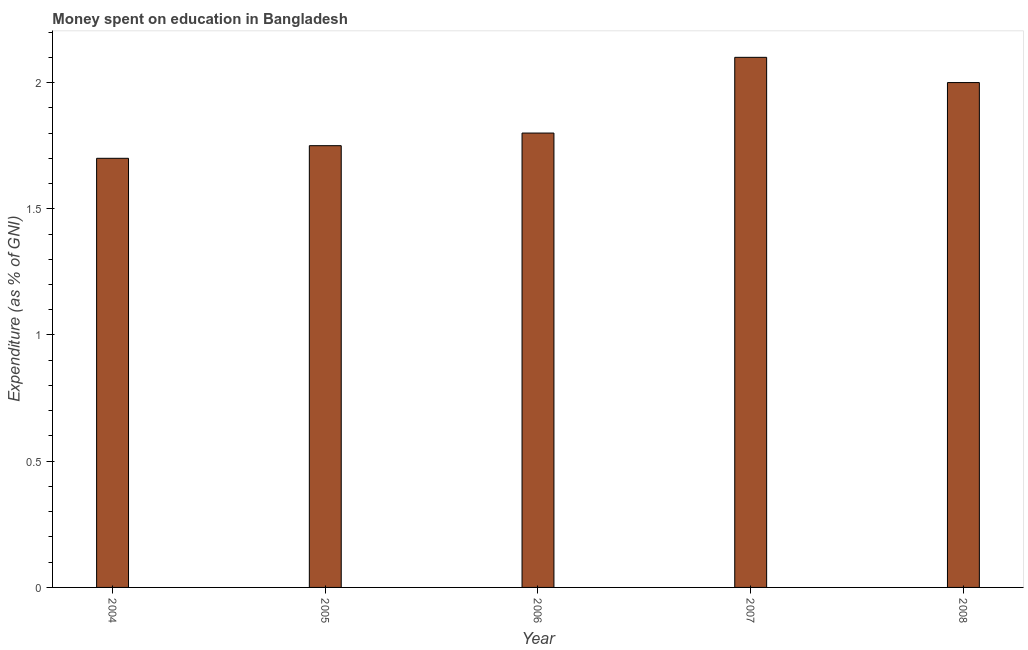What is the title of the graph?
Your answer should be compact. Money spent on education in Bangladesh. What is the label or title of the Y-axis?
Make the answer very short. Expenditure (as % of GNI). Across all years, what is the minimum expenditure on education?
Keep it short and to the point. 1.7. In which year was the expenditure on education minimum?
Provide a succinct answer. 2004. What is the sum of the expenditure on education?
Ensure brevity in your answer.  9.35. What is the difference between the expenditure on education in 2005 and 2008?
Provide a short and direct response. -0.25. What is the average expenditure on education per year?
Make the answer very short. 1.87. What is the median expenditure on education?
Your answer should be very brief. 1.8. What is the ratio of the expenditure on education in 2005 to that in 2007?
Offer a very short reply. 0.83. Is the expenditure on education in 2007 less than that in 2008?
Give a very brief answer. No. Is the sum of the expenditure on education in 2004 and 2006 greater than the maximum expenditure on education across all years?
Provide a short and direct response. Yes. What is the difference between the highest and the lowest expenditure on education?
Make the answer very short. 0.4. In how many years, is the expenditure on education greater than the average expenditure on education taken over all years?
Your response must be concise. 2. Are all the bars in the graph horizontal?
Offer a very short reply. No. Are the values on the major ticks of Y-axis written in scientific E-notation?
Keep it short and to the point. No. What is the Expenditure (as % of GNI) of 2004?
Make the answer very short. 1.7. What is the Expenditure (as % of GNI) of 2005?
Offer a very short reply. 1.75. What is the Expenditure (as % of GNI) in 2007?
Ensure brevity in your answer.  2.1. What is the Expenditure (as % of GNI) in 2008?
Offer a terse response. 2. What is the difference between the Expenditure (as % of GNI) in 2004 and 2005?
Offer a terse response. -0.05. What is the difference between the Expenditure (as % of GNI) in 2004 and 2007?
Keep it short and to the point. -0.4. What is the difference between the Expenditure (as % of GNI) in 2005 and 2007?
Provide a succinct answer. -0.35. What is the difference between the Expenditure (as % of GNI) in 2005 and 2008?
Your response must be concise. -0.25. What is the difference between the Expenditure (as % of GNI) in 2006 and 2007?
Provide a short and direct response. -0.3. What is the difference between the Expenditure (as % of GNI) in 2007 and 2008?
Your answer should be compact. 0.1. What is the ratio of the Expenditure (as % of GNI) in 2004 to that in 2005?
Offer a very short reply. 0.97. What is the ratio of the Expenditure (as % of GNI) in 2004 to that in 2006?
Your response must be concise. 0.94. What is the ratio of the Expenditure (as % of GNI) in 2004 to that in 2007?
Give a very brief answer. 0.81. What is the ratio of the Expenditure (as % of GNI) in 2004 to that in 2008?
Your response must be concise. 0.85. What is the ratio of the Expenditure (as % of GNI) in 2005 to that in 2006?
Provide a succinct answer. 0.97. What is the ratio of the Expenditure (as % of GNI) in 2005 to that in 2007?
Make the answer very short. 0.83. What is the ratio of the Expenditure (as % of GNI) in 2006 to that in 2007?
Provide a short and direct response. 0.86. What is the ratio of the Expenditure (as % of GNI) in 2007 to that in 2008?
Provide a short and direct response. 1.05. 